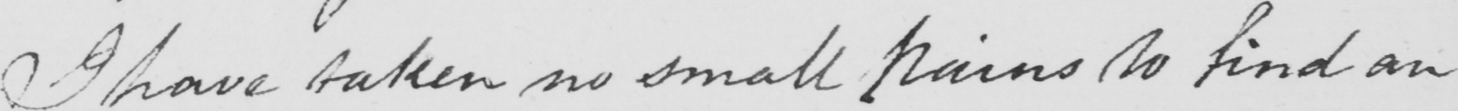What is written in this line of handwriting? I have taken no small pains to find an 